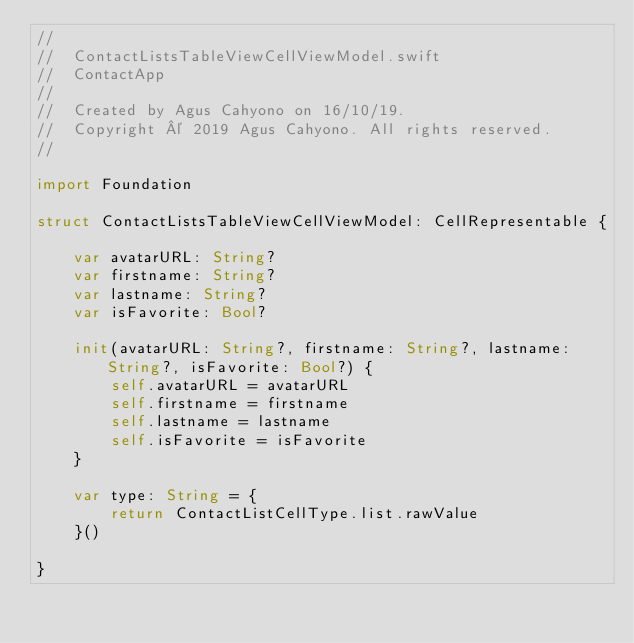<code> <loc_0><loc_0><loc_500><loc_500><_Swift_>//
//  ContactListsTableViewCellViewModel.swift
//  ContactApp
//
//  Created by Agus Cahyono on 16/10/19.
//  Copyright © 2019 Agus Cahyono. All rights reserved.
//

import Foundation

struct ContactListsTableViewCellViewModel: CellRepresentable {
    
    var avatarURL: String?
    var firstname: String?
    var lastname: String?
    var isFavorite: Bool?
    
    init(avatarURL: String?, firstname: String?, lastname: String?, isFavorite: Bool?) {
        self.avatarURL = avatarURL
        self.firstname = firstname
        self.lastname = lastname
        self.isFavorite = isFavorite
    }
    
    var type: String = {
        return ContactListCellType.list.rawValue
    }()
    
}
</code> 